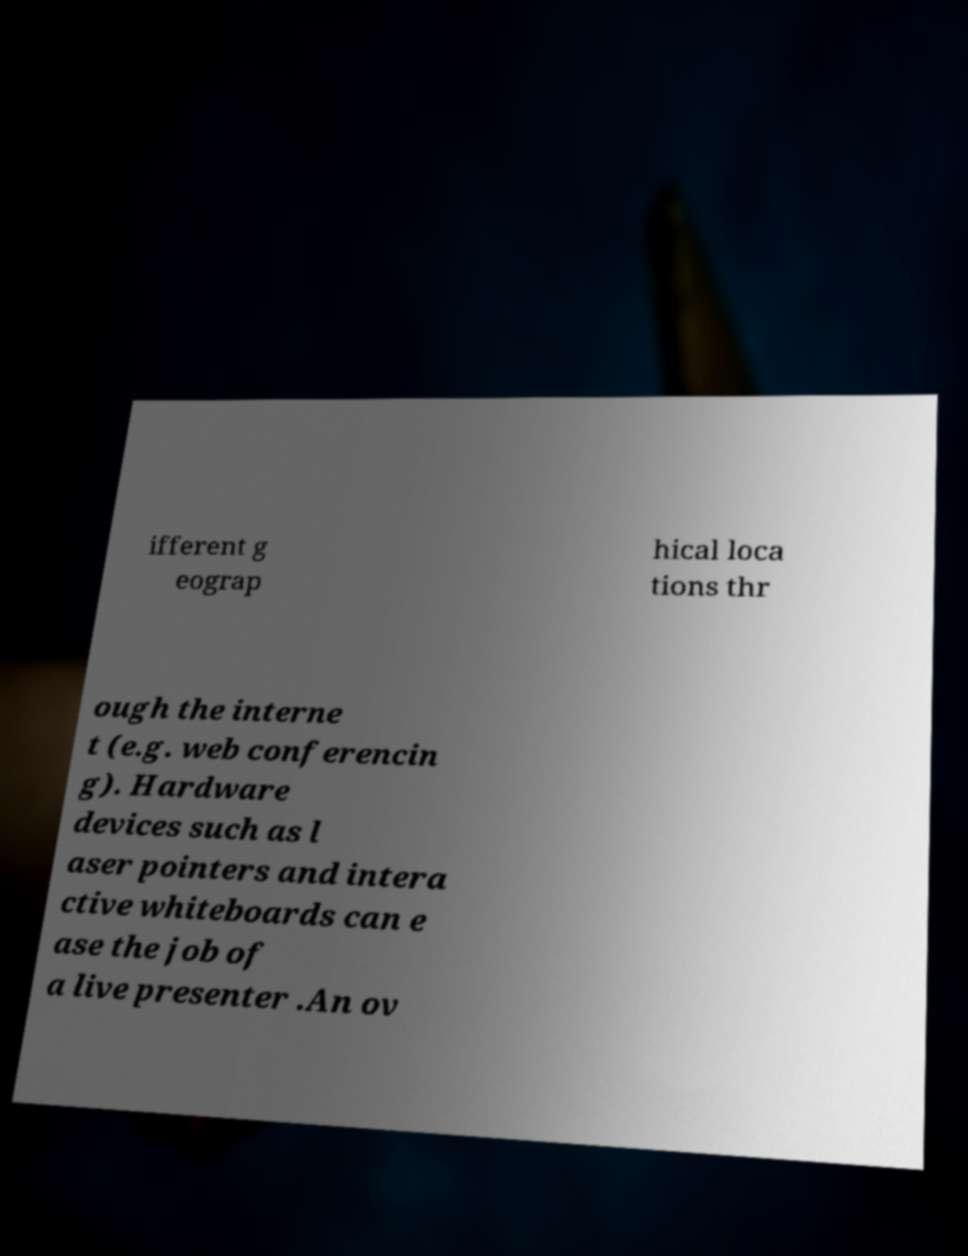Can you read and provide the text displayed in the image?This photo seems to have some interesting text. Can you extract and type it out for me? ifferent g eograp hical loca tions thr ough the interne t (e.g. web conferencin g). Hardware devices such as l aser pointers and intera ctive whiteboards can e ase the job of a live presenter .An ov 